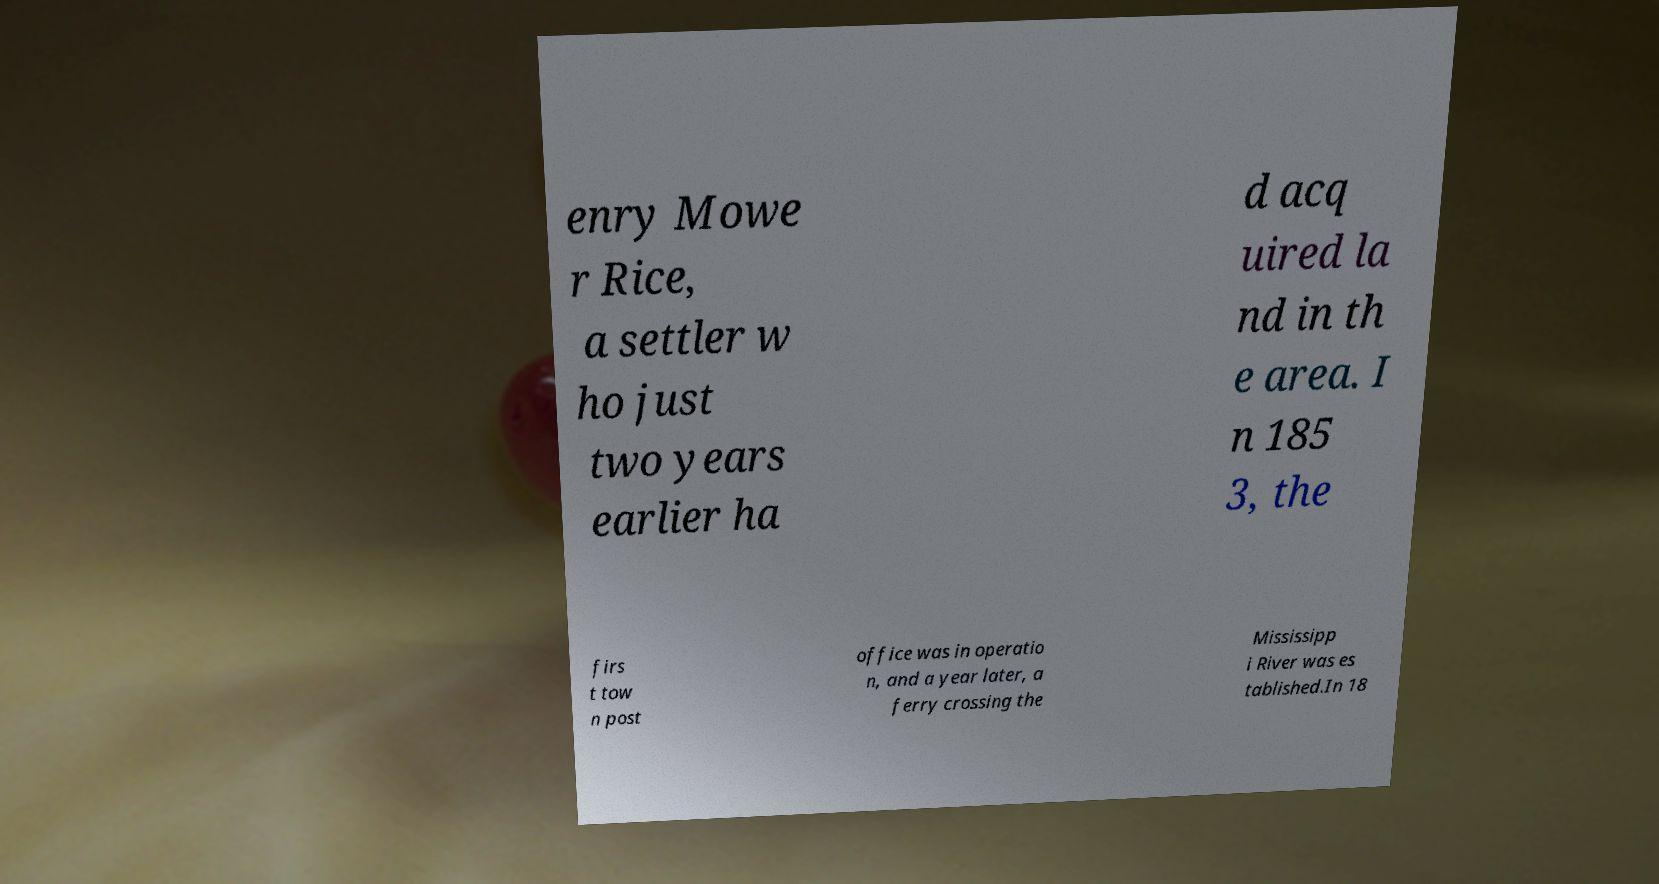Please read and relay the text visible in this image. What does it say? enry Mowe r Rice, a settler w ho just two years earlier ha d acq uired la nd in th e area. I n 185 3, the firs t tow n post office was in operatio n, and a year later, a ferry crossing the Mississipp i River was es tablished.In 18 